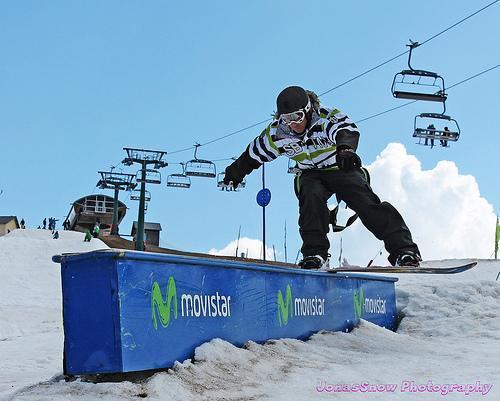How many people are in the photo?
Give a very brief answer. 1. 